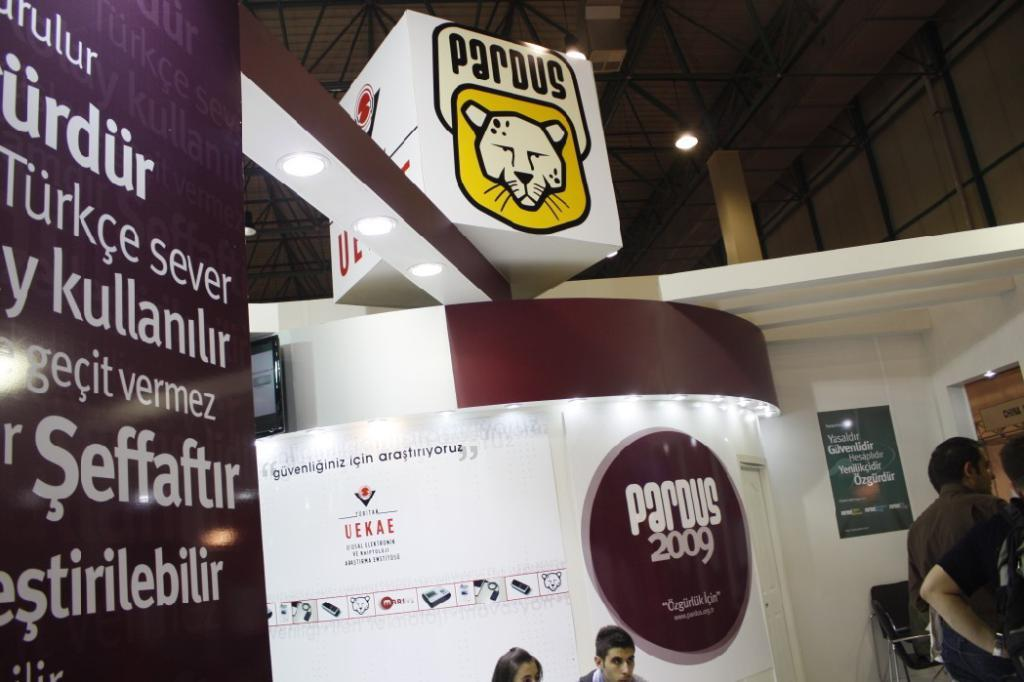<image>
Describe the image concisely. An event being held in a foreign city in the year 2009. 